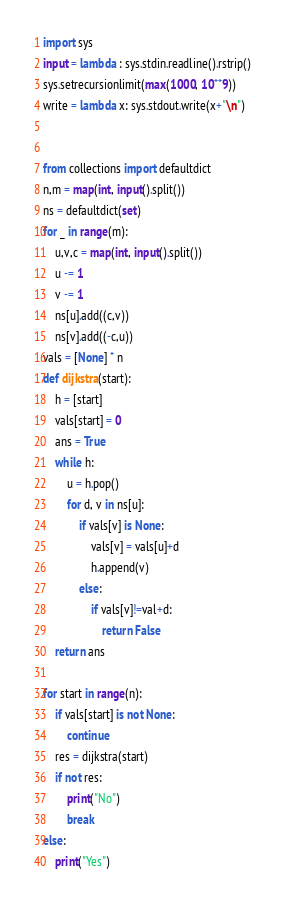Convert code to text. <code><loc_0><loc_0><loc_500><loc_500><_Python_>import sys
input = lambda : sys.stdin.readline().rstrip()
sys.setrecursionlimit(max(1000, 10**9))
write = lambda x: sys.stdout.write(x+"\n")


from collections import defaultdict
n,m = map(int, input().split())
ns = defaultdict(set)
for _ in range(m):
    u,v,c = map(int, input().split())
    u -= 1
    v -= 1
    ns[u].add((c,v))
    ns[v].add((-c,u))
vals = [None] * n
def dijkstra(start):
    h = [start]
    vals[start] = 0
    ans = True
    while h:
        u = h.pop()
        for d, v in ns[u]:
            if vals[v] is None:
                vals[v] = vals[u]+d
                h.append(v)
            else:
                if vals[v]!=val+d:
                    return False
    return ans

for start in range(n):
    if vals[start] is not None:
        continue
    res = dijkstra(start)
    if not res:
        print("No")
        break
else:
    print("Yes")</code> 